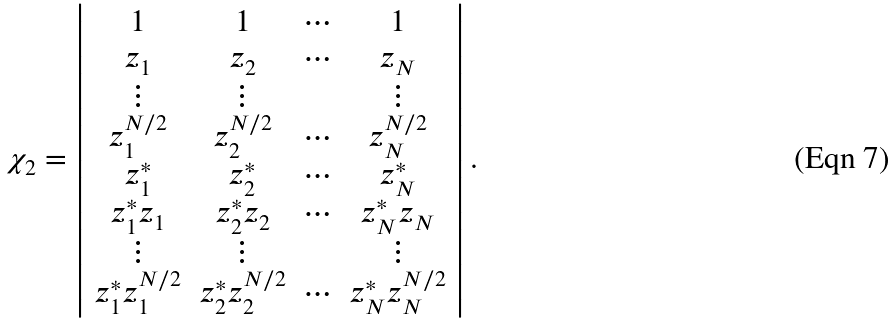Convert formula to latex. <formula><loc_0><loc_0><loc_500><loc_500>\chi _ { 2 } = \left | \begin{array} { c c c c } 1 & 1 & \cdots & 1 \\ z _ { 1 } & z _ { 2 } & \cdots & z _ { N } \\ \vdots & \vdots & & \vdots \\ z _ { 1 } ^ { N / 2 } & z _ { 2 } ^ { N / 2 } & \cdots & z _ { N } ^ { N / 2 } \\ z _ { 1 } ^ { * } & z _ { 2 } ^ { * } & \cdots & z _ { N } ^ { * } \\ z _ { 1 } ^ { * } z _ { 1 } & z _ { 2 } ^ { * } z _ { 2 } & \cdots & z _ { N } ^ { * } z _ { N } \\ \vdots & \vdots & & \vdots \\ z _ { 1 } ^ { * } z _ { 1 } ^ { N / 2 } & z _ { 2 } ^ { * } z _ { 2 } ^ { N / 2 } & \cdots & z _ { N } ^ { * } z _ { N } ^ { N / 2 } \end{array} \right | .</formula> 